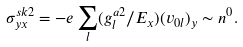Convert formula to latex. <formula><loc_0><loc_0><loc_500><loc_500>\sigma _ { y x } ^ { s k 2 } = - e \sum _ { l } ( g _ { l } ^ { a 2 } / E _ { x } ) ( v _ { 0 l } ) _ { y } \sim n ^ { 0 } .</formula> 